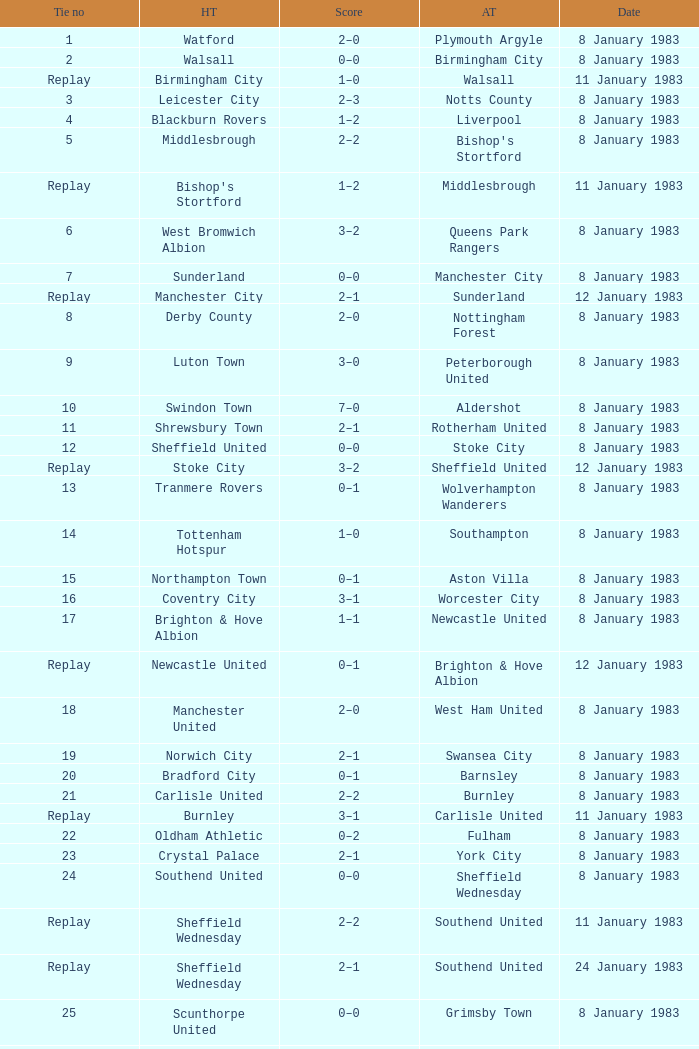What was the final score for the tie where Leeds United was the home team? 3–0. 